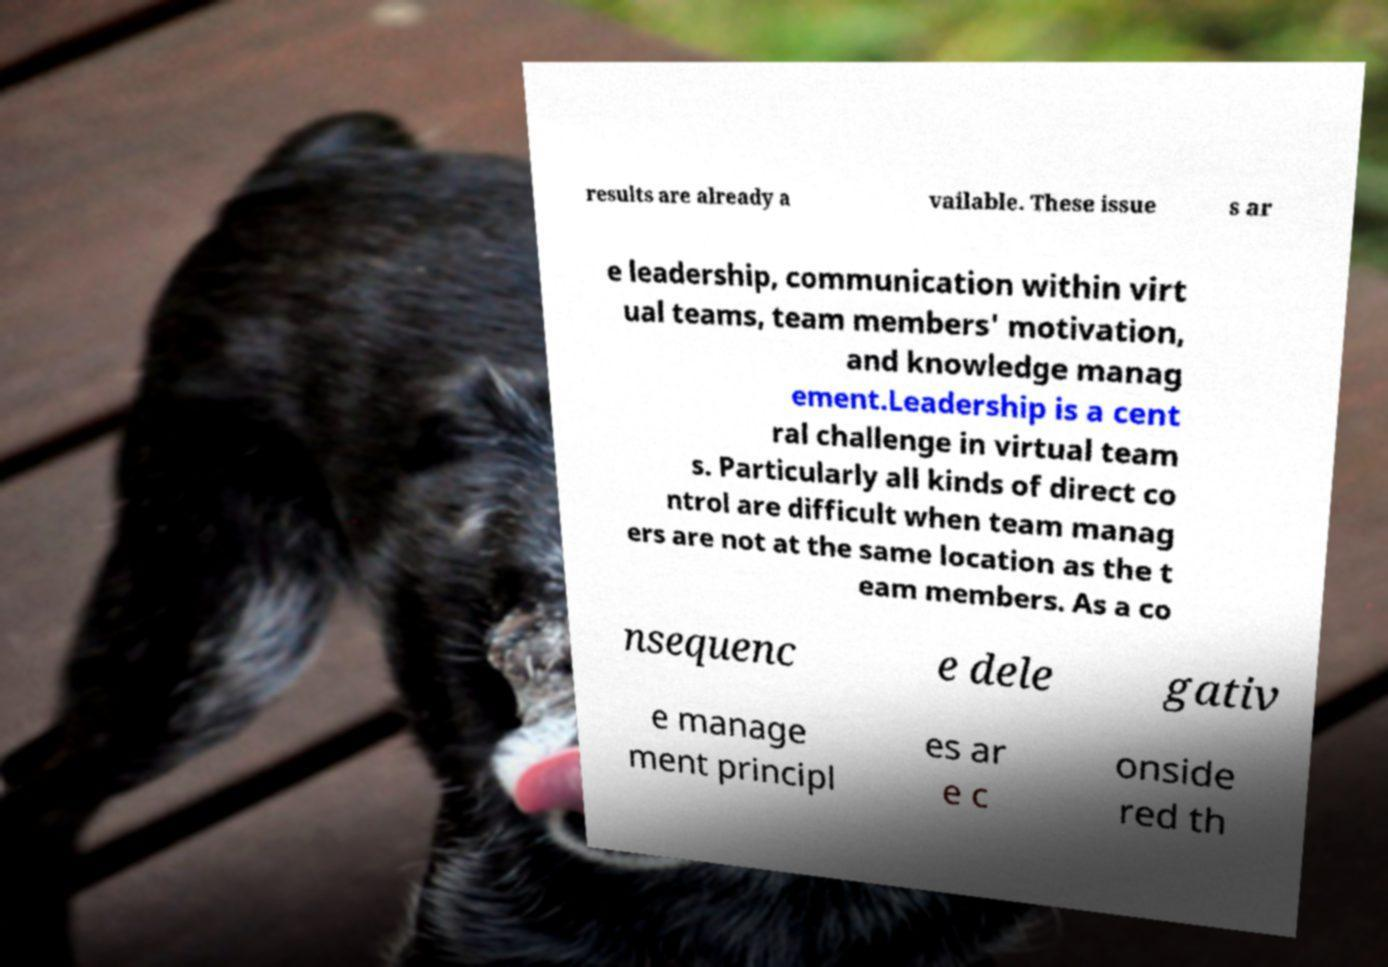What messages or text are displayed in this image? I need them in a readable, typed format. results are already a vailable. These issue s ar e leadership, communication within virt ual teams, team members' motivation, and knowledge manag ement.Leadership is a cent ral challenge in virtual team s. Particularly all kinds of direct co ntrol are difficult when team manag ers are not at the same location as the t eam members. As a co nsequenc e dele gativ e manage ment principl es ar e c onside red th 